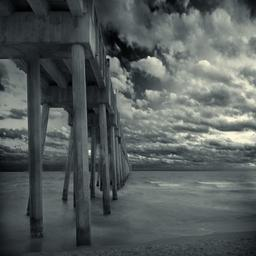Can you describe the weather conditions visible in the image? The weather in the image appears dynamic and possibly approaching inclement. The clouds are heavy and voluminous, indicating a significant buildup that could lead to rain. However, the absence of darkness in the clouds or other apparent precipitation suggests that if rain is coming, it is not yet occurring, leaving the scene with a dramatic yet tranquil atmosphere. 